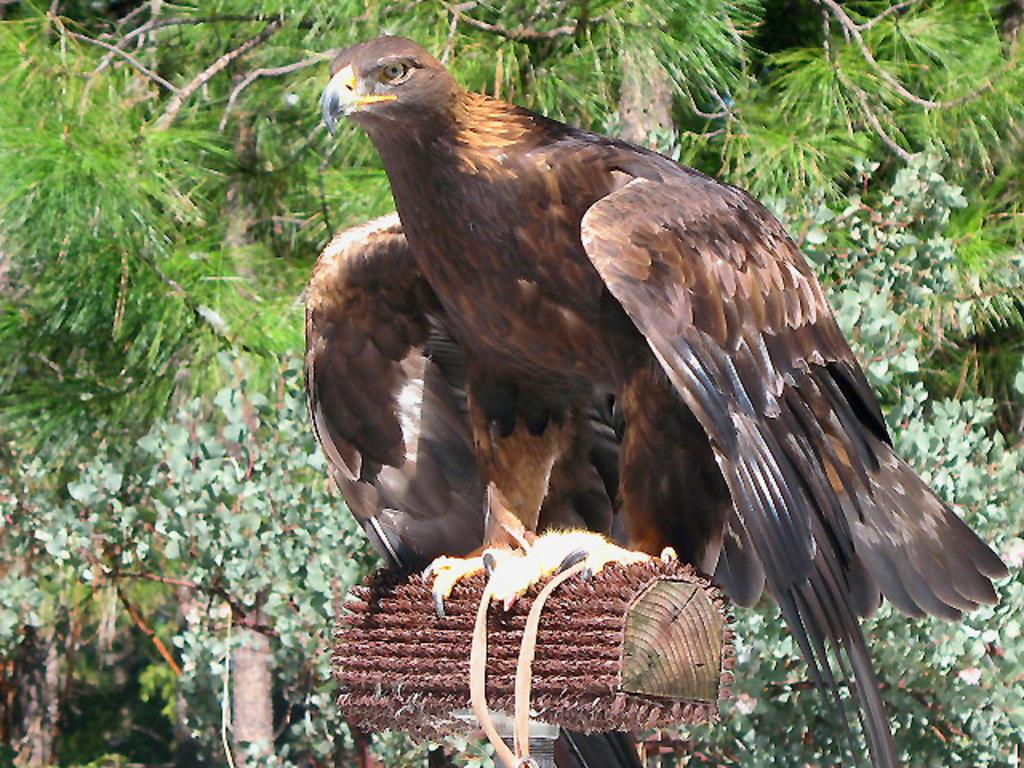What type of animal can be seen in the image? There is a bird in the image. What natural elements are present in the image? There are trees in the image. What material is the object made of in the image? There is a wooden object in the image. Where is the group of people shopping in the image? There is no group of people shopping in the image; it only features a bird, trees, and a wooden object. 